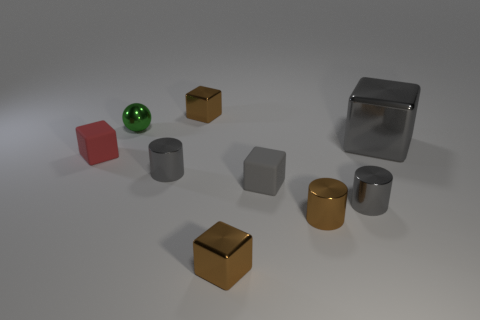Are there an equal number of green metallic objects that are to the left of the red block and metallic balls in front of the large shiny block?
Provide a succinct answer. Yes. Is there a large thing that has the same material as the tiny green sphere?
Offer a very short reply. Yes. Is the tiny brown object that is behind the big gray thing made of the same material as the small red block?
Keep it short and to the point. No. There is a object that is both behind the small red matte thing and in front of the shiny sphere; what size is it?
Provide a succinct answer. Large. What color is the big shiny thing?
Your response must be concise. Gray. What number of small red cubes are there?
Your answer should be very brief. 1. What number of shiny cubes are the same color as the tiny sphere?
Provide a succinct answer. 0. There is a small red matte thing that is left of the small brown shiny cylinder; is it the same shape as the tiny gray thing that is right of the tiny brown cylinder?
Give a very brief answer. No. There is a cylinder that is on the left side of the tiny metallic cylinder that is in front of the small gray shiny cylinder in front of the tiny gray rubber thing; what color is it?
Provide a short and direct response. Gray. There is a small matte object that is left of the small green metallic ball; what color is it?
Provide a short and direct response. Red. 